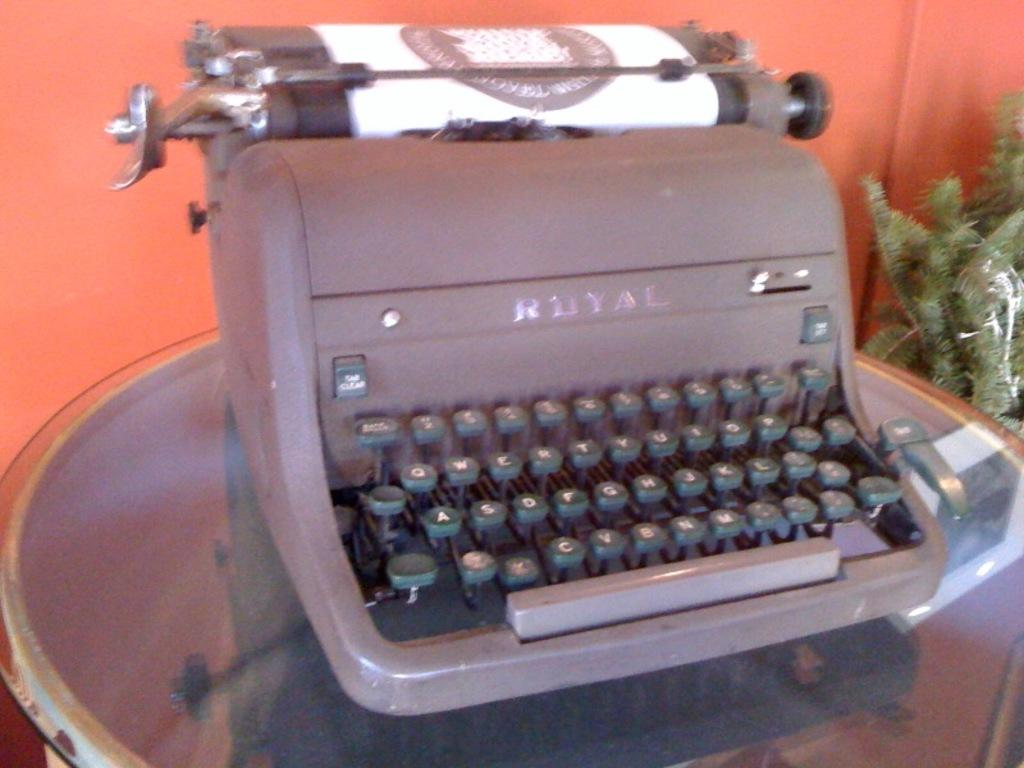<image>
Create a compact narrative representing the image presented. An ancient Royal typewriter sits on a display table. 